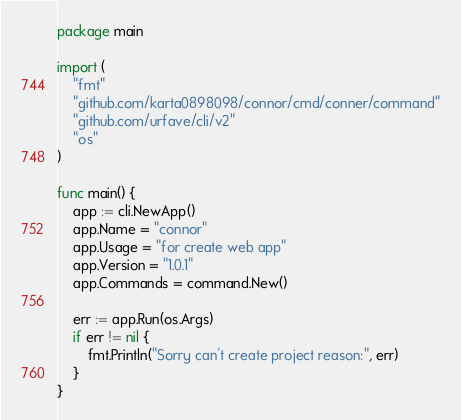<code> <loc_0><loc_0><loc_500><loc_500><_Go_>package main

import (
	"fmt"
	"github.com/karta0898098/connor/cmd/conner/command"
	"github.com/urfave/cli/v2"
	"os"
)

func main() {
	app := cli.NewApp()
	app.Name = "connor"
	app.Usage = "for create web app"
	app.Version = "1.0.1"
	app.Commands = command.New()

	err := app.Run(os.Args)
	if err != nil {
		fmt.Println("Sorry can't create project reason:", err)
	}
}
</code> 